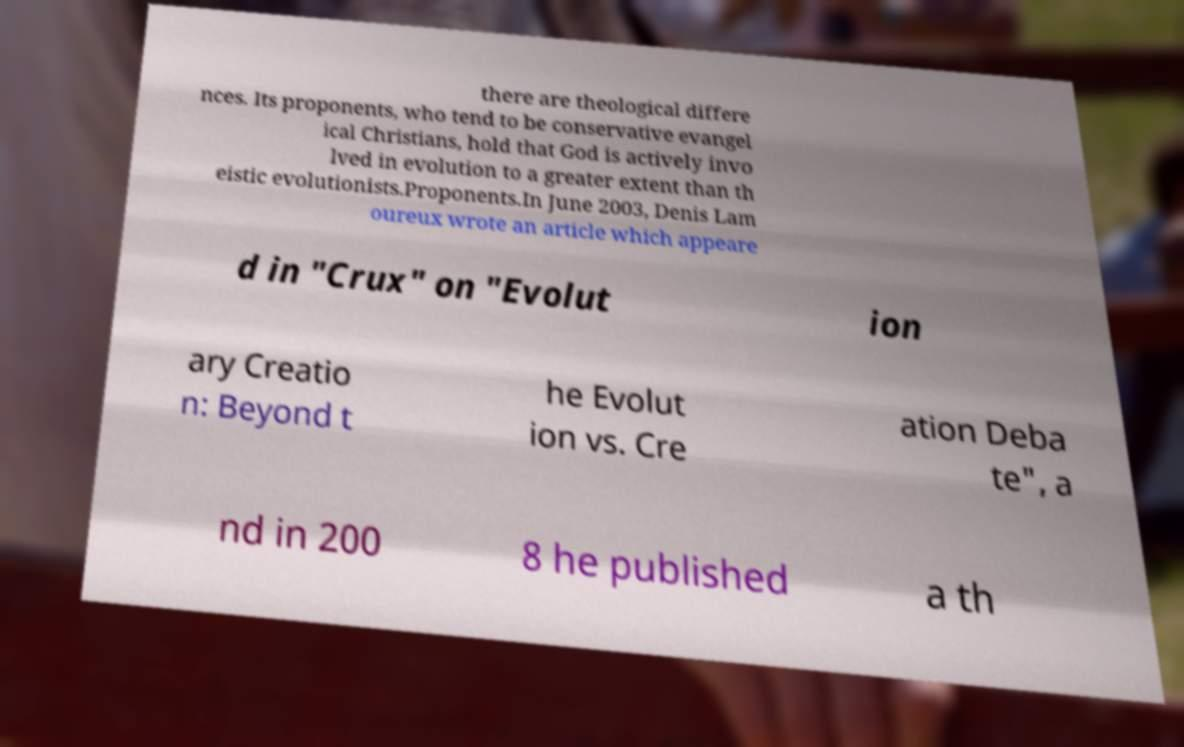Please read and relay the text visible in this image. What does it say? there are theological differe nces. Its proponents, who tend to be conservative evangel ical Christians, hold that God is actively invo lved in evolution to a greater extent than th eistic evolutionists.Proponents.In June 2003, Denis Lam oureux wrote an article which appeare d in "Crux" on "Evolut ion ary Creatio n: Beyond t he Evolut ion vs. Cre ation Deba te", a nd in 200 8 he published a th 